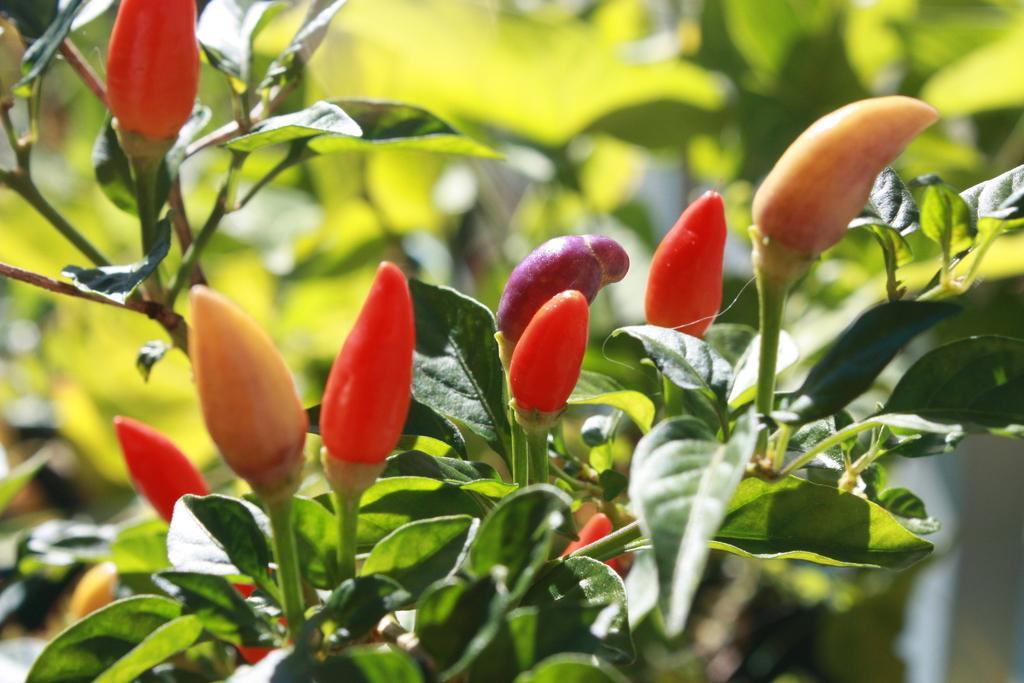Please provide a concise description of this image. In this picture we can see flower buds, leaves and in the background it is blurry. 